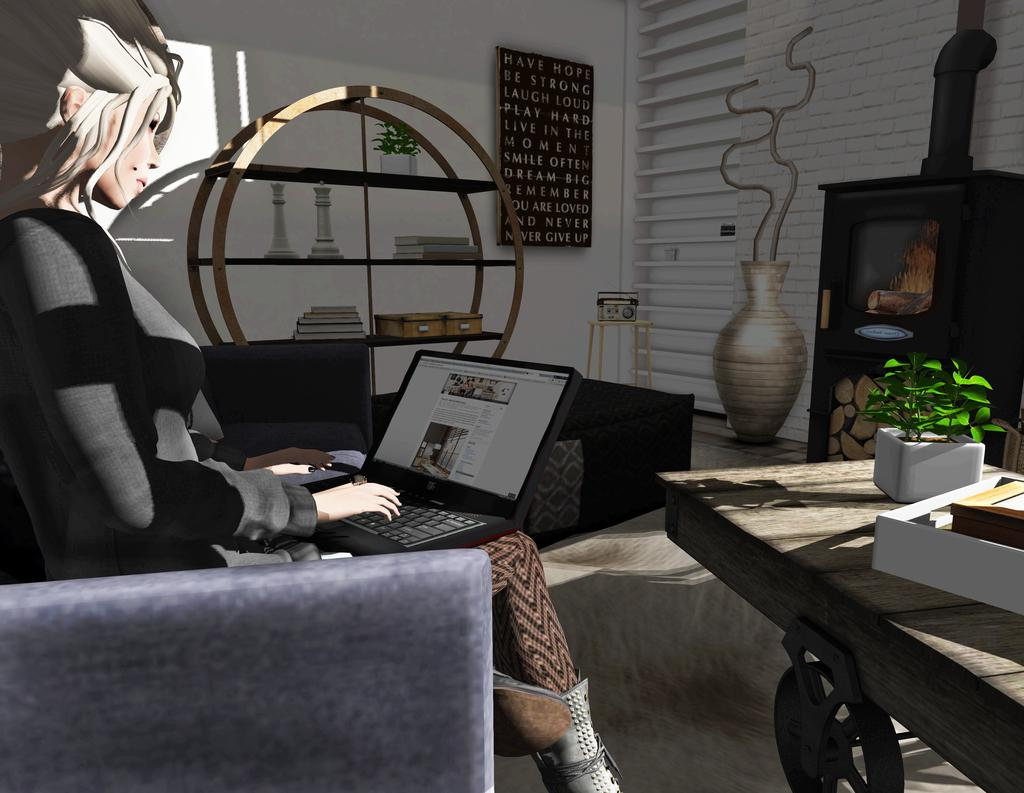What type of image is being described? The image is animated. What is the person in the image holding? The person is holding a laptop. What is in front of the person? There is a table in front of the person. What can be seen on the table? There is a flower vase on the table. What is attached to the wall in the image? There is a board attached to the wall. What type of twig is being used to plough the field in the image? There is no twig or field present in the image; it features an animated scene with a person holding a laptop and other objects. 